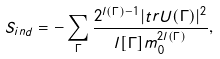<formula> <loc_0><loc_0><loc_500><loc_500>S _ { i n d } = - \sum _ { \Gamma } \frac { 2 ^ { l ( \Gamma ) - 1 } | t r U ( \Gamma ) | ^ { 2 } } { l [ \Gamma ] m _ { 0 } ^ { 2 l ( \Gamma ) } } ,</formula> 